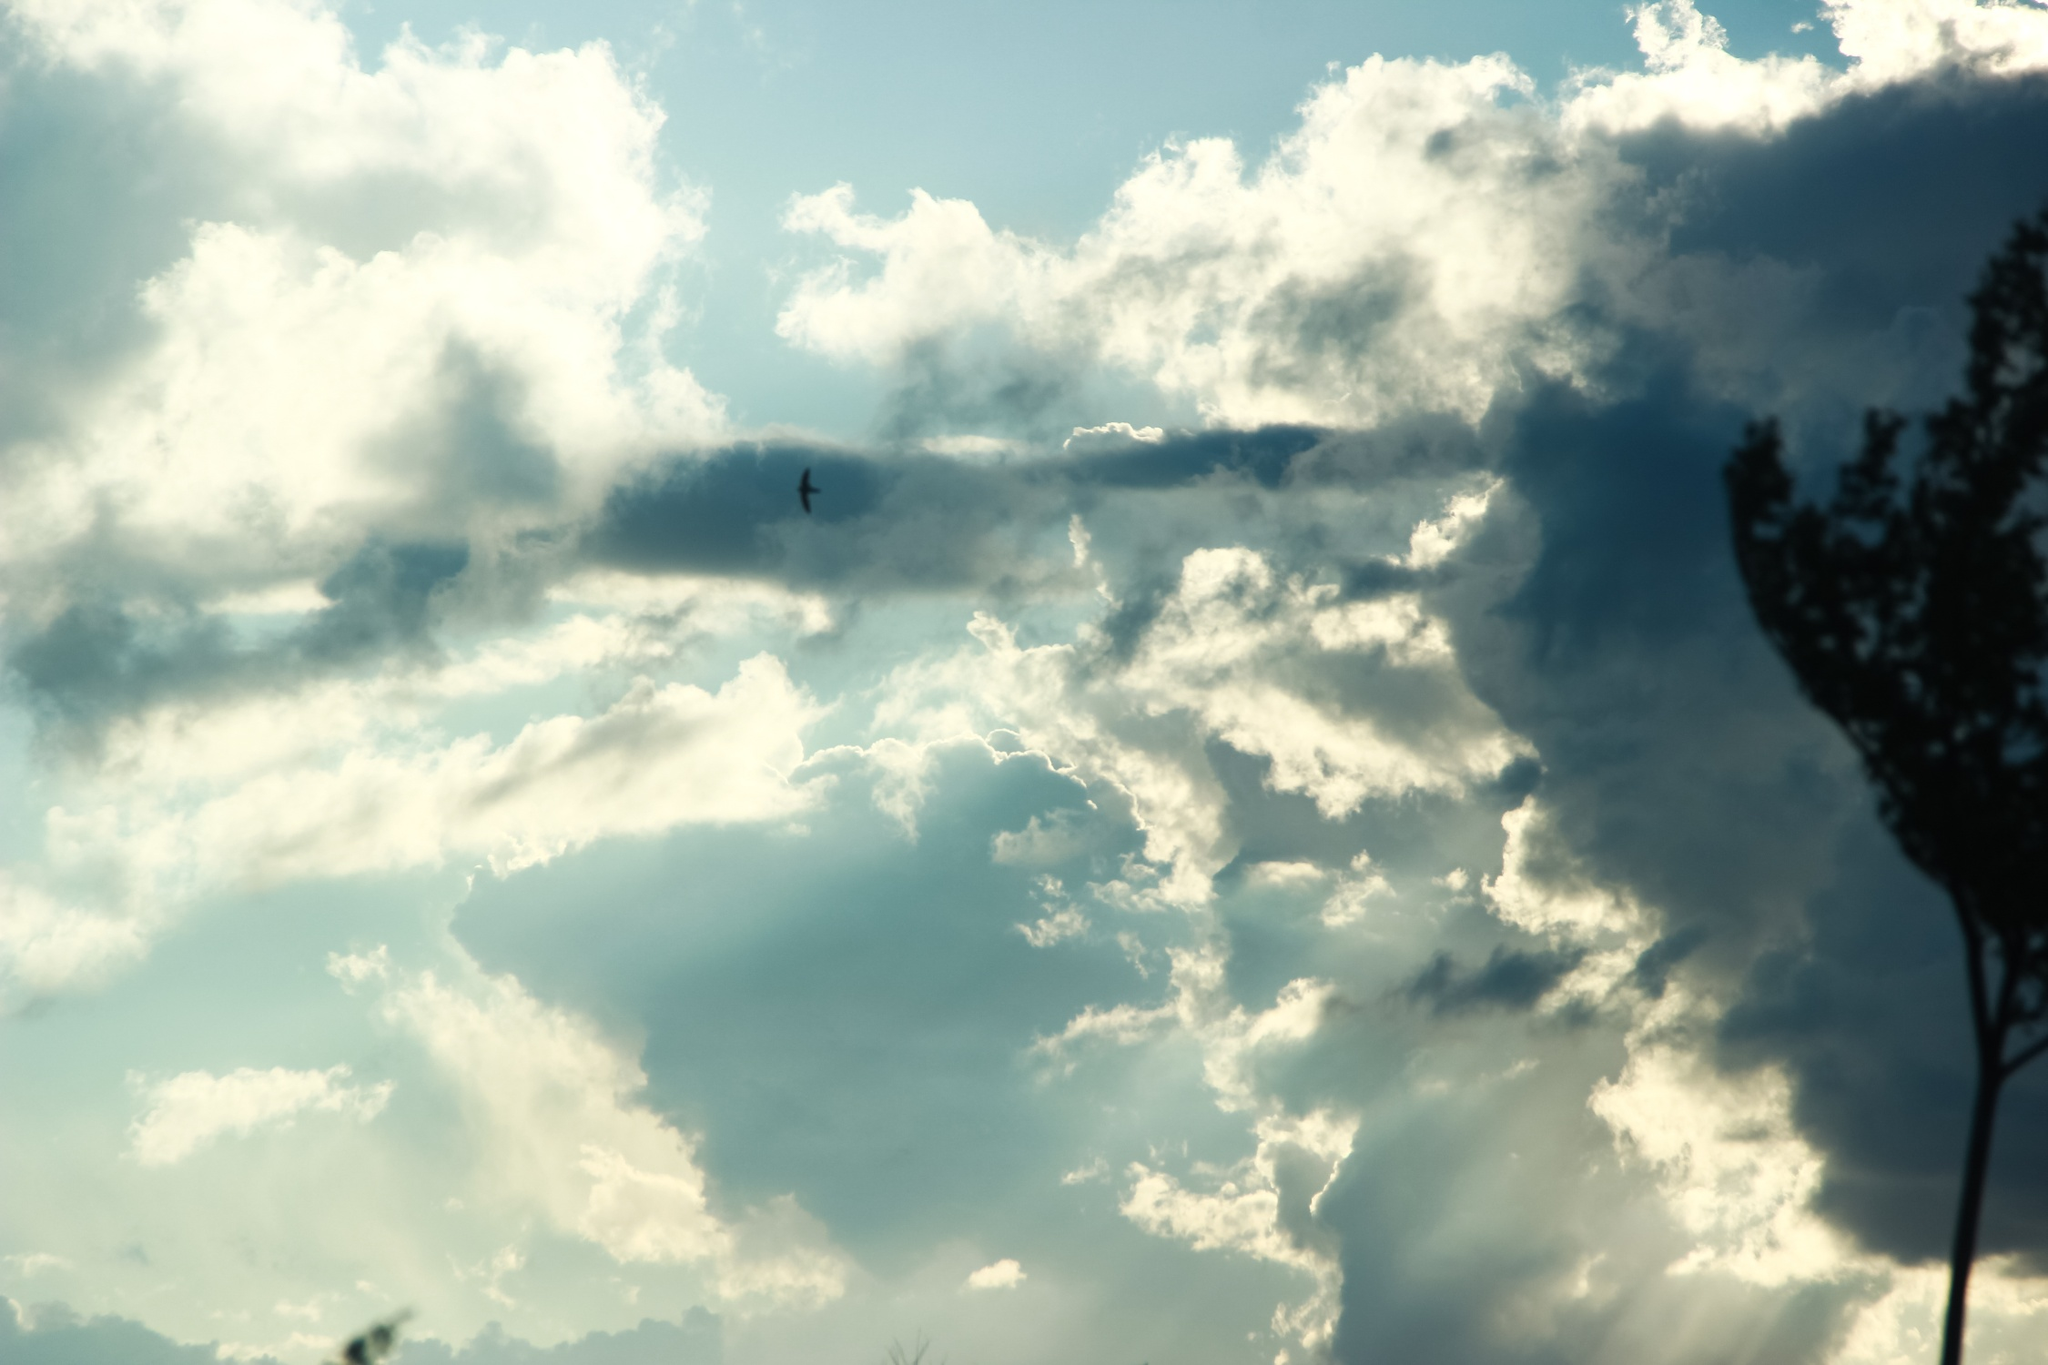What is this photo about'? This photo beautifully captures a serene scene filled with a sense of tranquility and freedom. The expansive sky, adorned with varying shades of blue, is peppered with clouds in different forms—some are wispy while others present a more solid and dense texture. On the right side of the frame stands a tall, leafless tree, its dark silhouette contrasting dramatically against the lighter sky. Its outstretched branches appear to be reaching for the heavens, adding a stark yet striking element to the scene. From a low angle perspective, the viewer’s gaze naturally follows the tree's outline upward, emphasizing the vastness of the sky. Adding a vibrant touch to the otherwise still environment, a small bird, perhaps a sparrow or a finch, is captured mid-flight in the center of the image. This bird not only injects life and movement into the scene but also symbolizes freedom. The composition skillfully balances the image with the tree on one side and the open sky on the other, creating a visually pleasing and symbolic contrast that can evoke a sense of peace and contemplation. Although the image does not directly inform about any specific landmark, the depicted serenity and natural beauty hint at a rural or natural setting. 